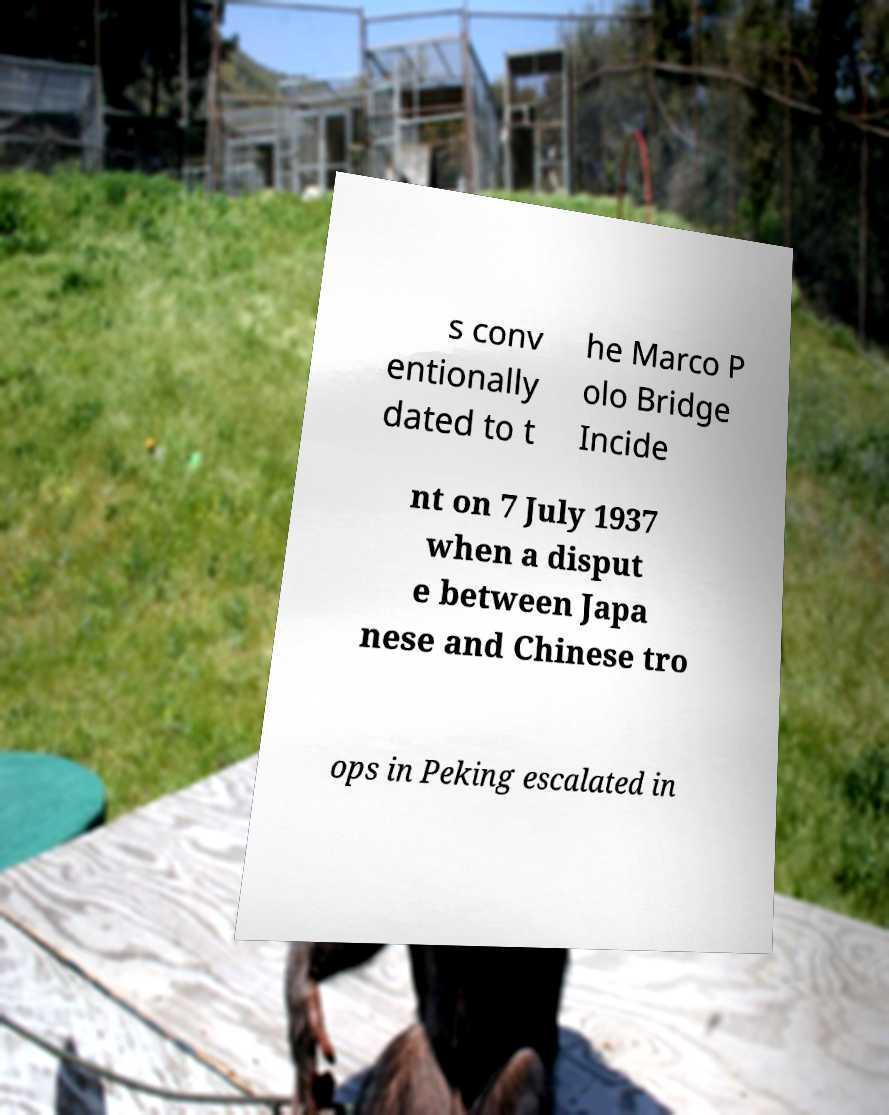Could you extract and type out the text from this image? s conv entionally dated to t he Marco P olo Bridge Incide nt on 7 July 1937 when a disput e between Japa nese and Chinese tro ops in Peking escalated in 